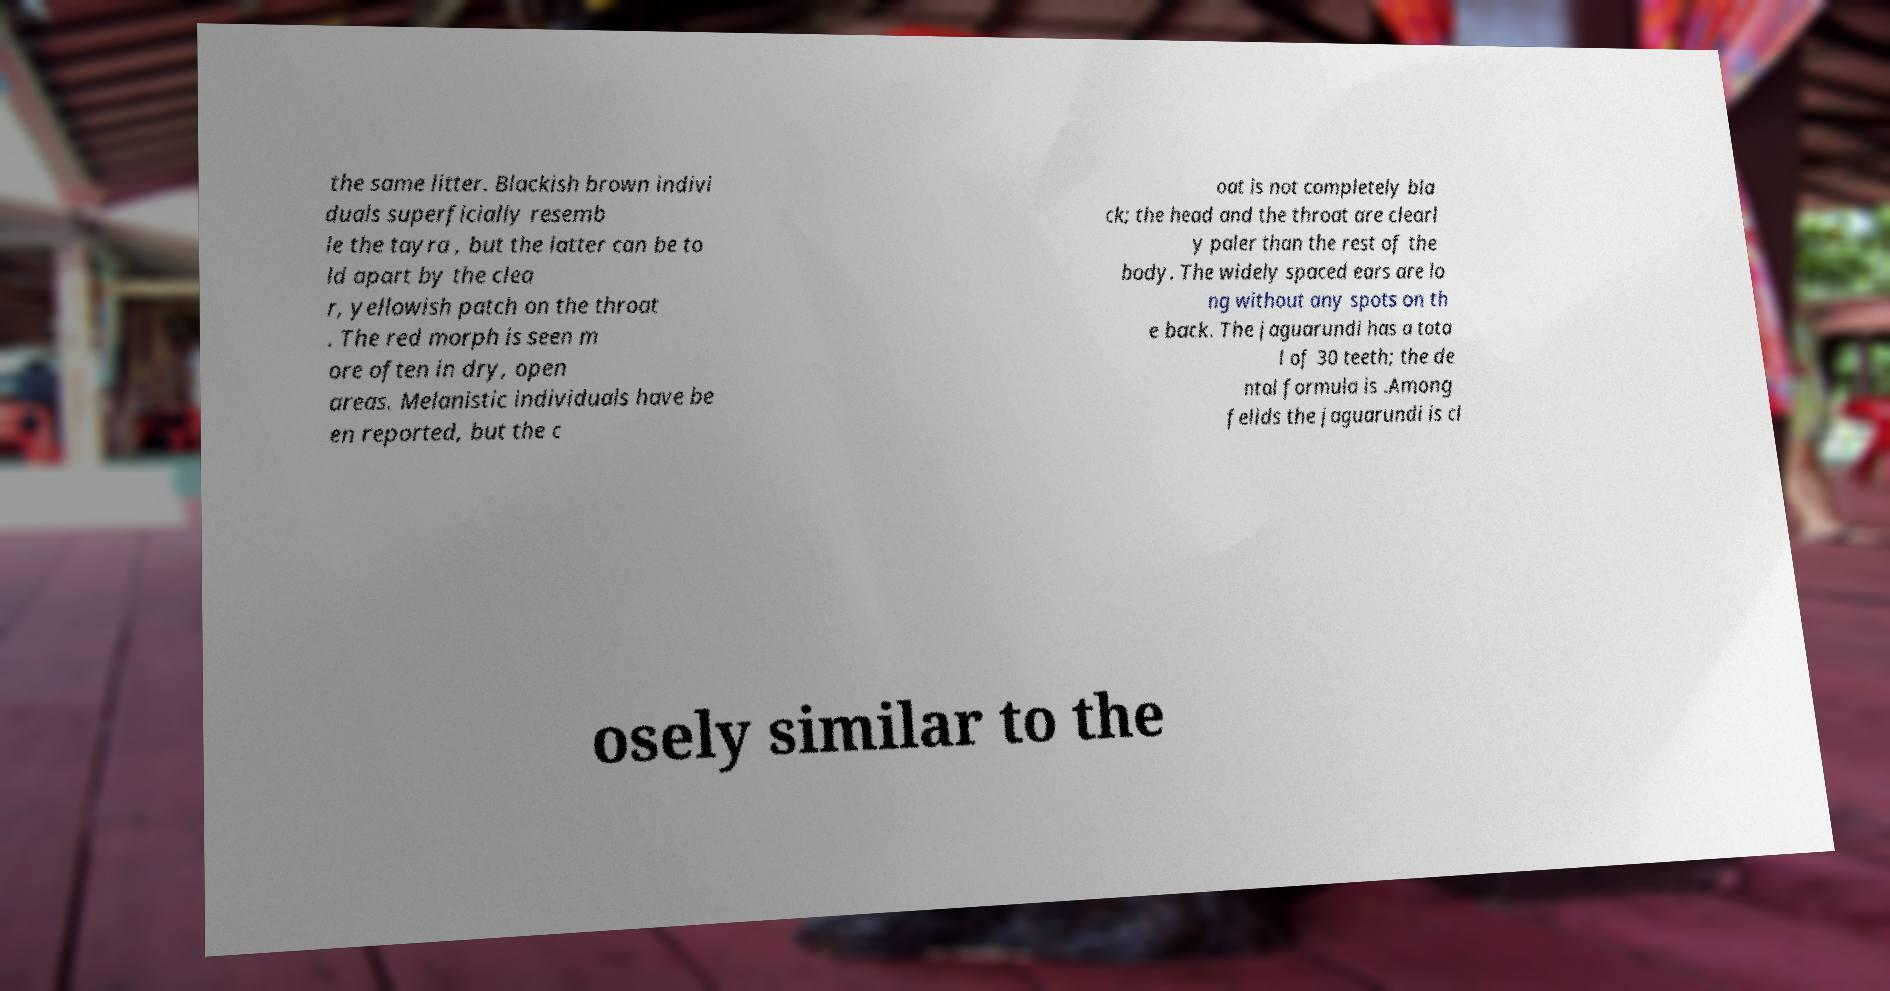Please read and relay the text visible in this image. What does it say? the same litter. Blackish brown indivi duals superficially resemb le the tayra , but the latter can be to ld apart by the clea r, yellowish patch on the throat . The red morph is seen m ore often in dry, open areas. Melanistic individuals have be en reported, but the c oat is not completely bla ck; the head and the throat are clearl y paler than the rest of the body. The widely spaced ears are lo ng without any spots on th e back. The jaguarundi has a tota l of 30 teeth; the de ntal formula is .Among felids the jaguarundi is cl osely similar to the 